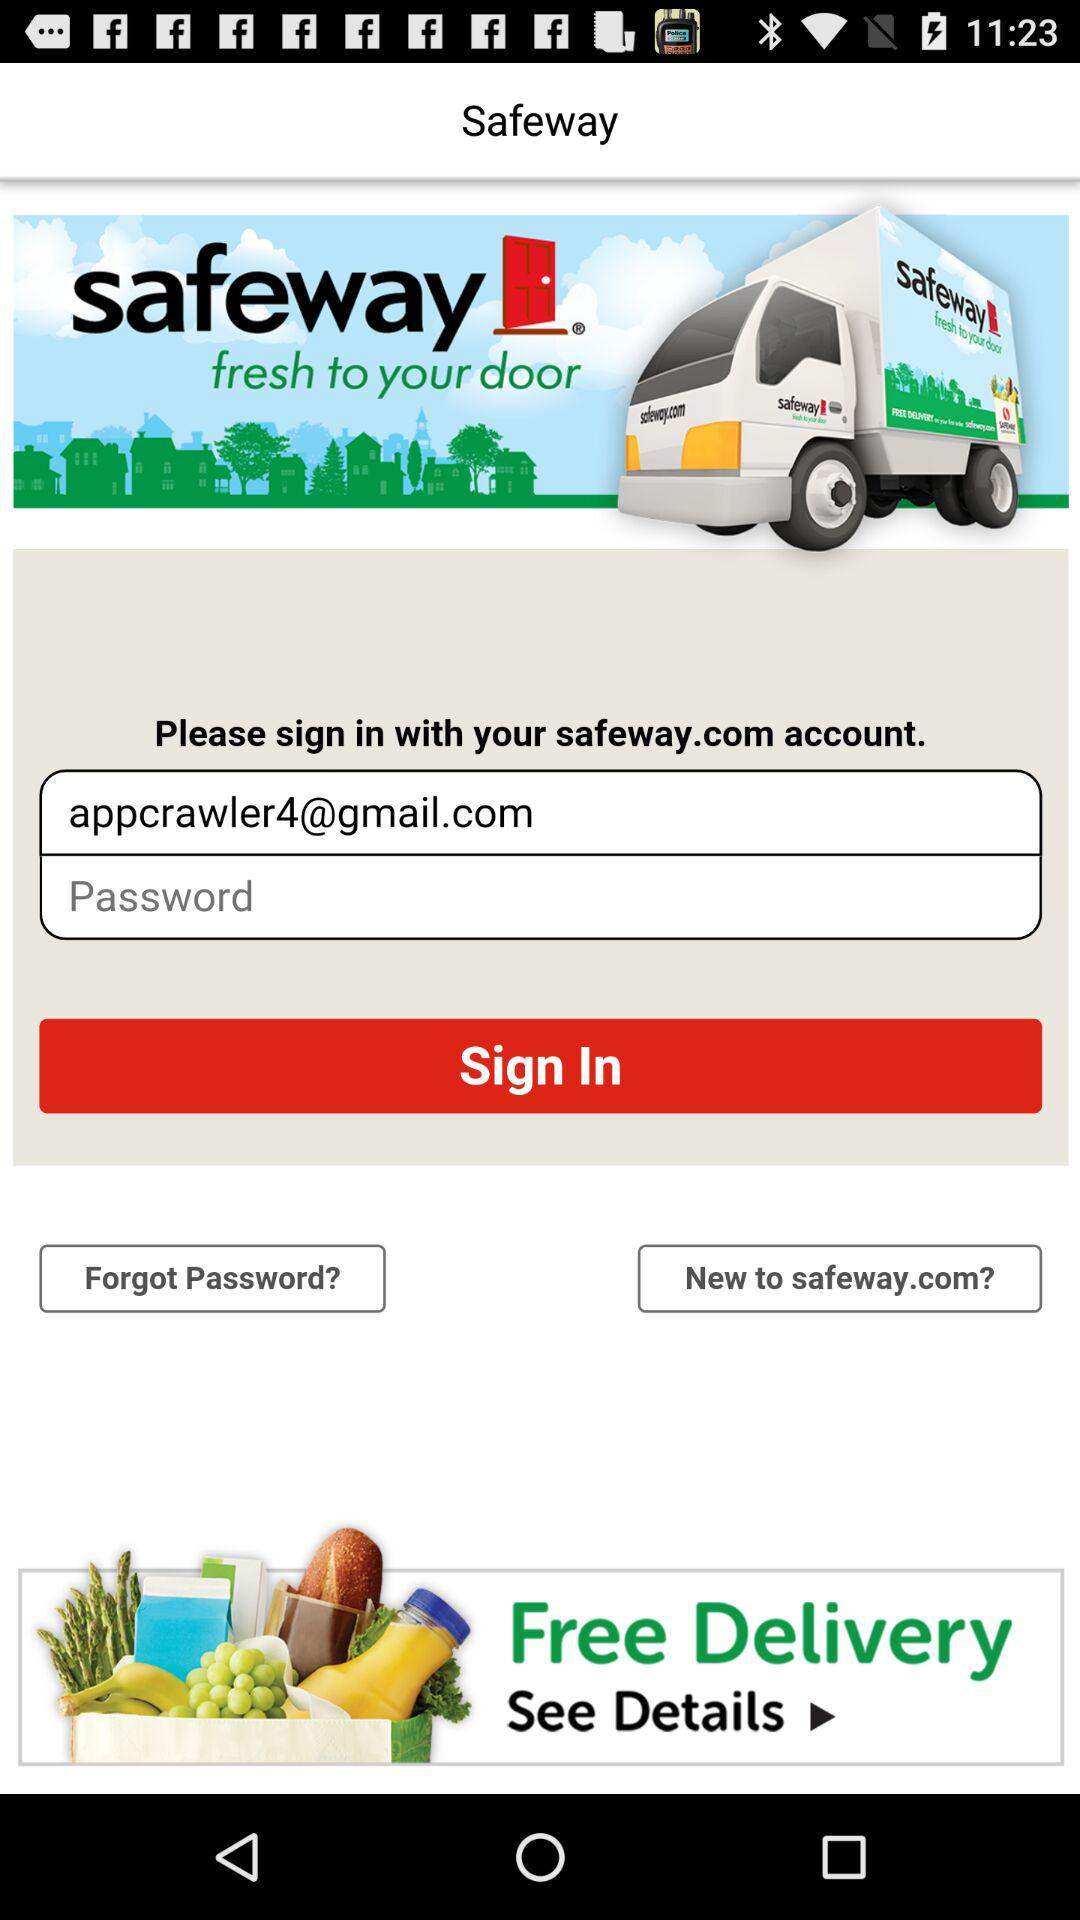What is the sign-in email address? The sign-in email address is appcrawler4@gmail.com. 